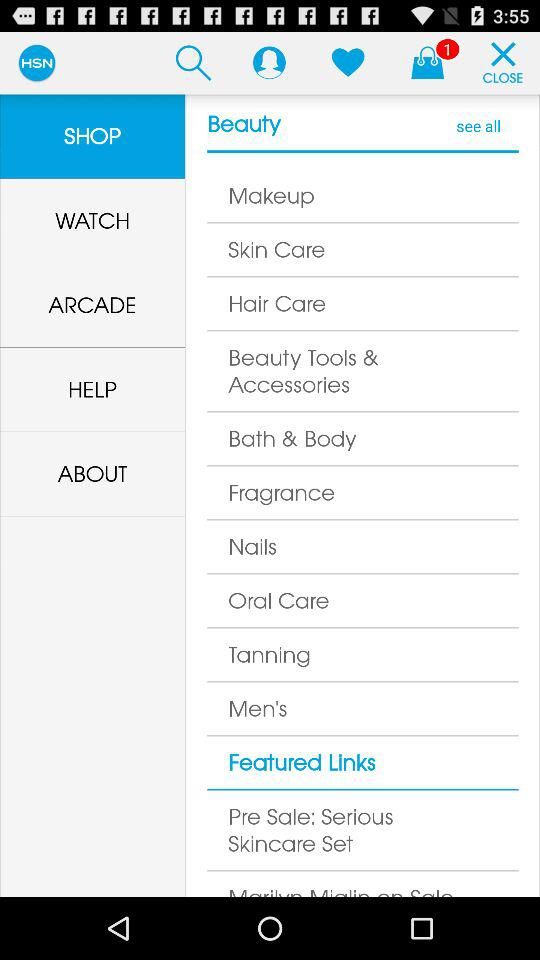How many items are in the bag? There is 1 item in the bag. 